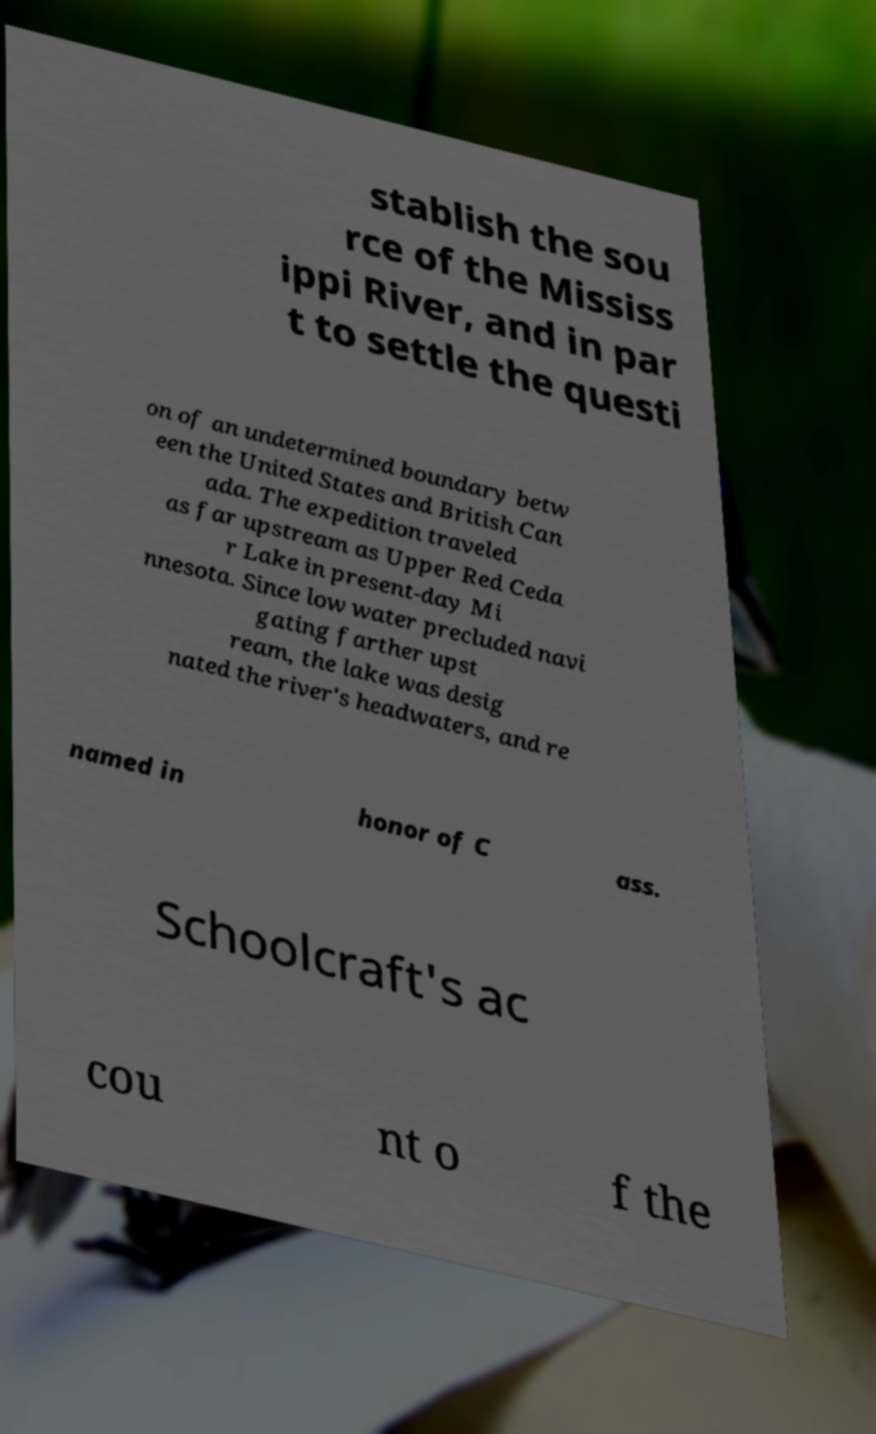Could you assist in decoding the text presented in this image and type it out clearly? stablish the sou rce of the Mississ ippi River, and in par t to settle the questi on of an undetermined boundary betw een the United States and British Can ada. The expedition traveled as far upstream as Upper Red Ceda r Lake in present-day Mi nnesota. Since low water precluded navi gating farther upst ream, the lake was desig nated the river's headwaters, and re named in honor of C ass. Schoolcraft's ac cou nt o f the 